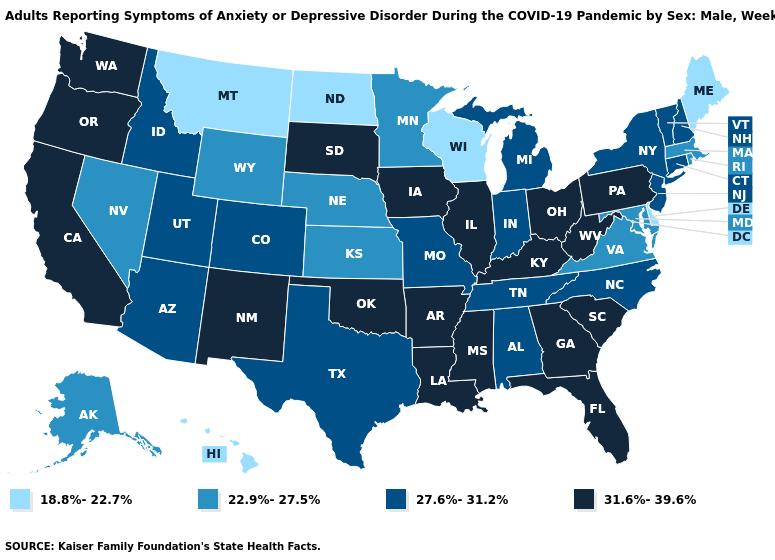What is the value of Utah?
Short answer required. 27.6%-31.2%. What is the value of Connecticut?
Write a very short answer. 27.6%-31.2%. How many symbols are there in the legend?
Quick response, please. 4. What is the value of North Carolina?
Short answer required. 27.6%-31.2%. Name the states that have a value in the range 27.6%-31.2%?
Quick response, please. Alabama, Arizona, Colorado, Connecticut, Idaho, Indiana, Michigan, Missouri, New Hampshire, New Jersey, New York, North Carolina, Tennessee, Texas, Utah, Vermont. Name the states that have a value in the range 22.9%-27.5%?
Be succinct. Alaska, Kansas, Maryland, Massachusetts, Minnesota, Nebraska, Nevada, Rhode Island, Virginia, Wyoming. Which states have the lowest value in the USA?
Write a very short answer. Delaware, Hawaii, Maine, Montana, North Dakota, Wisconsin. What is the value of North Dakota?
Be succinct. 18.8%-22.7%. What is the lowest value in states that border New Hampshire?
Short answer required. 18.8%-22.7%. Is the legend a continuous bar?
Be succinct. No. Which states have the lowest value in the USA?
Keep it brief. Delaware, Hawaii, Maine, Montana, North Dakota, Wisconsin. Is the legend a continuous bar?
Quick response, please. No. What is the lowest value in the USA?
Give a very brief answer. 18.8%-22.7%. Name the states that have a value in the range 22.9%-27.5%?
Answer briefly. Alaska, Kansas, Maryland, Massachusetts, Minnesota, Nebraska, Nevada, Rhode Island, Virginia, Wyoming. What is the highest value in the USA?
Short answer required. 31.6%-39.6%. 